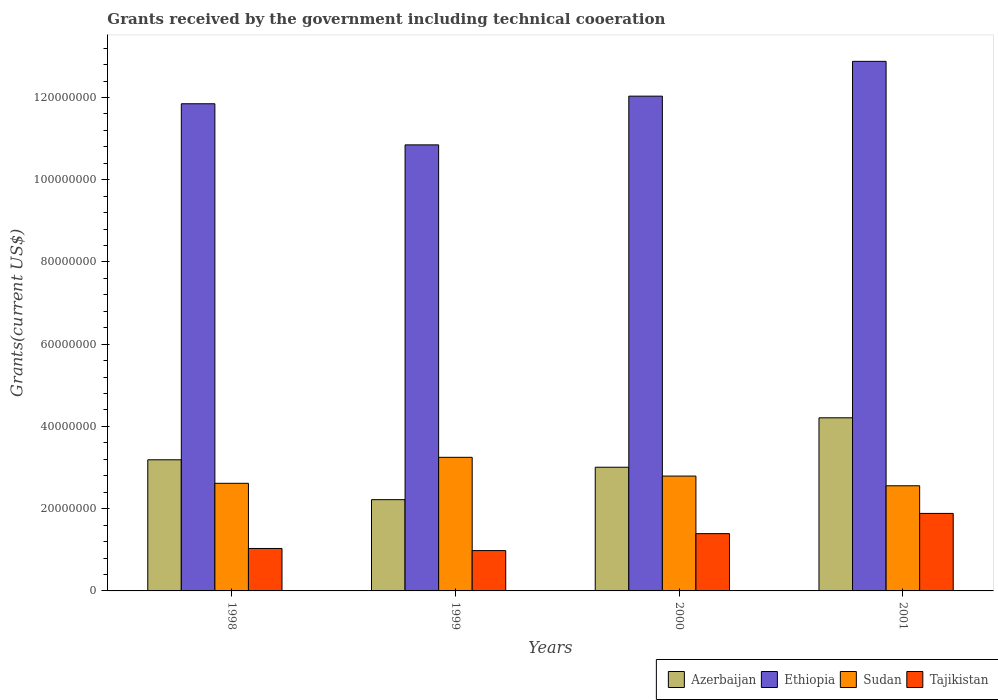How many different coloured bars are there?
Provide a succinct answer. 4. Are the number of bars on each tick of the X-axis equal?
Make the answer very short. Yes. How many bars are there on the 1st tick from the left?
Ensure brevity in your answer.  4. What is the label of the 2nd group of bars from the left?
Give a very brief answer. 1999. What is the total grants received by the government in Sudan in 1999?
Offer a terse response. 3.25e+07. Across all years, what is the maximum total grants received by the government in Ethiopia?
Ensure brevity in your answer.  1.29e+08. Across all years, what is the minimum total grants received by the government in Ethiopia?
Make the answer very short. 1.08e+08. In which year was the total grants received by the government in Tajikistan maximum?
Offer a very short reply. 2001. In which year was the total grants received by the government in Azerbaijan minimum?
Offer a terse response. 1999. What is the total total grants received by the government in Azerbaijan in the graph?
Offer a terse response. 1.26e+08. What is the difference between the total grants received by the government in Azerbaijan in 1999 and that in 2000?
Give a very brief answer. -7.89e+06. What is the difference between the total grants received by the government in Azerbaijan in 2000 and the total grants received by the government in Ethiopia in 2001?
Your answer should be very brief. -9.87e+07. What is the average total grants received by the government in Sudan per year?
Your answer should be compact. 2.80e+07. In the year 1999, what is the difference between the total grants received by the government in Tajikistan and total grants received by the government in Ethiopia?
Give a very brief answer. -9.87e+07. What is the ratio of the total grants received by the government in Sudan in 1999 to that in 2001?
Make the answer very short. 1.27. What is the difference between the highest and the second highest total grants received by the government in Tajikistan?
Offer a very short reply. 4.92e+06. What is the difference between the highest and the lowest total grants received by the government in Azerbaijan?
Provide a short and direct response. 1.99e+07. What does the 3rd bar from the left in 1999 represents?
Your response must be concise. Sudan. What does the 1st bar from the right in 1998 represents?
Offer a very short reply. Tajikistan. Is it the case that in every year, the sum of the total grants received by the government in Ethiopia and total grants received by the government in Tajikistan is greater than the total grants received by the government in Azerbaijan?
Make the answer very short. Yes. Are all the bars in the graph horizontal?
Your answer should be compact. No. Does the graph contain any zero values?
Keep it short and to the point. No. Does the graph contain grids?
Offer a very short reply. No. Where does the legend appear in the graph?
Make the answer very short. Bottom right. How many legend labels are there?
Keep it short and to the point. 4. How are the legend labels stacked?
Provide a succinct answer. Horizontal. What is the title of the graph?
Your response must be concise. Grants received by the government including technical cooeration. What is the label or title of the X-axis?
Offer a very short reply. Years. What is the label or title of the Y-axis?
Your answer should be compact. Grants(current US$). What is the Grants(current US$) of Azerbaijan in 1998?
Offer a very short reply. 3.19e+07. What is the Grants(current US$) of Ethiopia in 1998?
Provide a short and direct response. 1.18e+08. What is the Grants(current US$) in Sudan in 1998?
Provide a succinct answer. 2.62e+07. What is the Grants(current US$) in Tajikistan in 1998?
Your answer should be compact. 1.03e+07. What is the Grants(current US$) in Azerbaijan in 1999?
Your response must be concise. 2.22e+07. What is the Grants(current US$) in Ethiopia in 1999?
Provide a short and direct response. 1.08e+08. What is the Grants(current US$) of Sudan in 1999?
Your response must be concise. 3.25e+07. What is the Grants(current US$) of Tajikistan in 1999?
Make the answer very short. 9.81e+06. What is the Grants(current US$) of Azerbaijan in 2000?
Make the answer very short. 3.01e+07. What is the Grants(current US$) of Ethiopia in 2000?
Your answer should be very brief. 1.20e+08. What is the Grants(current US$) of Sudan in 2000?
Ensure brevity in your answer.  2.79e+07. What is the Grants(current US$) in Tajikistan in 2000?
Keep it short and to the point. 1.39e+07. What is the Grants(current US$) of Azerbaijan in 2001?
Give a very brief answer. 4.21e+07. What is the Grants(current US$) in Ethiopia in 2001?
Offer a terse response. 1.29e+08. What is the Grants(current US$) of Sudan in 2001?
Ensure brevity in your answer.  2.56e+07. What is the Grants(current US$) in Tajikistan in 2001?
Offer a terse response. 1.88e+07. Across all years, what is the maximum Grants(current US$) of Azerbaijan?
Ensure brevity in your answer.  4.21e+07. Across all years, what is the maximum Grants(current US$) in Ethiopia?
Provide a succinct answer. 1.29e+08. Across all years, what is the maximum Grants(current US$) of Sudan?
Ensure brevity in your answer.  3.25e+07. Across all years, what is the maximum Grants(current US$) in Tajikistan?
Your answer should be compact. 1.88e+07. Across all years, what is the minimum Grants(current US$) of Azerbaijan?
Provide a succinct answer. 2.22e+07. Across all years, what is the minimum Grants(current US$) in Ethiopia?
Offer a very short reply. 1.08e+08. Across all years, what is the minimum Grants(current US$) of Sudan?
Provide a short and direct response. 2.56e+07. Across all years, what is the minimum Grants(current US$) of Tajikistan?
Provide a short and direct response. 9.81e+06. What is the total Grants(current US$) in Azerbaijan in the graph?
Your response must be concise. 1.26e+08. What is the total Grants(current US$) in Ethiopia in the graph?
Your answer should be compact. 4.76e+08. What is the total Grants(current US$) in Sudan in the graph?
Provide a succinct answer. 1.12e+08. What is the total Grants(current US$) of Tajikistan in the graph?
Provide a succinct answer. 5.29e+07. What is the difference between the Grants(current US$) of Azerbaijan in 1998 and that in 1999?
Your response must be concise. 9.70e+06. What is the difference between the Grants(current US$) of Ethiopia in 1998 and that in 1999?
Your response must be concise. 1.00e+07. What is the difference between the Grants(current US$) in Sudan in 1998 and that in 1999?
Your response must be concise. -6.32e+06. What is the difference between the Grants(current US$) of Tajikistan in 1998 and that in 1999?
Keep it short and to the point. 5.10e+05. What is the difference between the Grants(current US$) of Azerbaijan in 1998 and that in 2000?
Your answer should be compact. 1.81e+06. What is the difference between the Grants(current US$) of Ethiopia in 1998 and that in 2000?
Your answer should be compact. -1.85e+06. What is the difference between the Grants(current US$) in Sudan in 1998 and that in 2000?
Give a very brief answer. -1.76e+06. What is the difference between the Grants(current US$) in Tajikistan in 1998 and that in 2000?
Make the answer very short. -3.61e+06. What is the difference between the Grants(current US$) of Azerbaijan in 1998 and that in 2001?
Your answer should be compact. -1.02e+07. What is the difference between the Grants(current US$) of Ethiopia in 1998 and that in 2001?
Provide a short and direct response. -1.03e+07. What is the difference between the Grants(current US$) of Sudan in 1998 and that in 2001?
Ensure brevity in your answer.  6.00e+05. What is the difference between the Grants(current US$) of Tajikistan in 1998 and that in 2001?
Ensure brevity in your answer.  -8.53e+06. What is the difference between the Grants(current US$) of Azerbaijan in 1999 and that in 2000?
Make the answer very short. -7.89e+06. What is the difference between the Grants(current US$) in Ethiopia in 1999 and that in 2000?
Your answer should be very brief. -1.18e+07. What is the difference between the Grants(current US$) of Sudan in 1999 and that in 2000?
Give a very brief answer. 4.56e+06. What is the difference between the Grants(current US$) in Tajikistan in 1999 and that in 2000?
Provide a short and direct response. -4.12e+06. What is the difference between the Grants(current US$) of Azerbaijan in 1999 and that in 2001?
Your response must be concise. -1.99e+07. What is the difference between the Grants(current US$) in Ethiopia in 1999 and that in 2001?
Your response must be concise. -2.03e+07. What is the difference between the Grants(current US$) of Sudan in 1999 and that in 2001?
Your answer should be compact. 6.92e+06. What is the difference between the Grants(current US$) of Tajikistan in 1999 and that in 2001?
Your answer should be very brief. -9.04e+06. What is the difference between the Grants(current US$) of Azerbaijan in 2000 and that in 2001?
Your answer should be very brief. -1.20e+07. What is the difference between the Grants(current US$) in Ethiopia in 2000 and that in 2001?
Provide a short and direct response. -8.46e+06. What is the difference between the Grants(current US$) in Sudan in 2000 and that in 2001?
Keep it short and to the point. 2.36e+06. What is the difference between the Grants(current US$) in Tajikistan in 2000 and that in 2001?
Provide a succinct answer. -4.92e+06. What is the difference between the Grants(current US$) in Azerbaijan in 1998 and the Grants(current US$) in Ethiopia in 1999?
Your response must be concise. -7.66e+07. What is the difference between the Grants(current US$) of Azerbaijan in 1998 and the Grants(current US$) of Sudan in 1999?
Provide a short and direct response. -6.00e+05. What is the difference between the Grants(current US$) of Azerbaijan in 1998 and the Grants(current US$) of Tajikistan in 1999?
Give a very brief answer. 2.21e+07. What is the difference between the Grants(current US$) in Ethiopia in 1998 and the Grants(current US$) in Sudan in 1999?
Give a very brief answer. 8.60e+07. What is the difference between the Grants(current US$) of Ethiopia in 1998 and the Grants(current US$) of Tajikistan in 1999?
Your response must be concise. 1.09e+08. What is the difference between the Grants(current US$) in Sudan in 1998 and the Grants(current US$) in Tajikistan in 1999?
Ensure brevity in your answer.  1.64e+07. What is the difference between the Grants(current US$) in Azerbaijan in 1998 and the Grants(current US$) in Ethiopia in 2000?
Your answer should be very brief. -8.84e+07. What is the difference between the Grants(current US$) of Azerbaijan in 1998 and the Grants(current US$) of Sudan in 2000?
Keep it short and to the point. 3.96e+06. What is the difference between the Grants(current US$) in Azerbaijan in 1998 and the Grants(current US$) in Tajikistan in 2000?
Provide a succinct answer. 1.80e+07. What is the difference between the Grants(current US$) in Ethiopia in 1998 and the Grants(current US$) in Sudan in 2000?
Your response must be concise. 9.05e+07. What is the difference between the Grants(current US$) in Ethiopia in 1998 and the Grants(current US$) in Tajikistan in 2000?
Provide a short and direct response. 1.05e+08. What is the difference between the Grants(current US$) in Sudan in 1998 and the Grants(current US$) in Tajikistan in 2000?
Offer a terse response. 1.22e+07. What is the difference between the Grants(current US$) in Azerbaijan in 1998 and the Grants(current US$) in Ethiopia in 2001?
Give a very brief answer. -9.69e+07. What is the difference between the Grants(current US$) of Azerbaijan in 1998 and the Grants(current US$) of Sudan in 2001?
Make the answer very short. 6.32e+06. What is the difference between the Grants(current US$) in Azerbaijan in 1998 and the Grants(current US$) in Tajikistan in 2001?
Your answer should be compact. 1.30e+07. What is the difference between the Grants(current US$) in Ethiopia in 1998 and the Grants(current US$) in Sudan in 2001?
Your answer should be very brief. 9.29e+07. What is the difference between the Grants(current US$) of Ethiopia in 1998 and the Grants(current US$) of Tajikistan in 2001?
Provide a succinct answer. 9.96e+07. What is the difference between the Grants(current US$) of Sudan in 1998 and the Grants(current US$) of Tajikistan in 2001?
Keep it short and to the point. 7.32e+06. What is the difference between the Grants(current US$) in Azerbaijan in 1999 and the Grants(current US$) in Ethiopia in 2000?
Ensure brevity in your answer.  -9.81e+07. What is the difference between the Grants(current US$) in Azerbaijan in 1999 and the Grants(current US$) in Sudan in 2000?
Provide a succinct answer. -5.74e+06. What is the difference between the Grants(current US$) of Azerbaijan in 1999 and the Grants(current US$) of Tajikistan in 2000?
Offer a very short reply. 8.26e+06. What is the difference between the Grants(current US$) in Ethiopia in 1999 and the Grants(current US$) in Sudan in 2000?
Your answer should be compact. 8.05e+07. What is the difference between the Grants(current US$) in Ethiopia in 1999 and the Grants(current US$) in Tajikistan in 2000?
Offer a very short reply. 9.45e+07. What is the difference between the Grants(current US$) of Sudan in 1999 and the Grants(current US$) of Tajikistan in 2000?
Give a very brief answer. 1.86e+07. What is the difference between the Grants(current US$) in Azerbaijan in 1999 and the Grants(current US$) in Ethiopia in 2001?
Your answer should be compact. -1.07e+08. What is the difference between the Grants(current US$) in Azerbaijan in 1999 and the Grants(current US$) in Sudan in 2001?
Ensure brevity in your answer.  -3.38e+06. What is the difference between the Grants(current US$) of Azerbaijan in 1999 and the Grants(current US$) of Tajikistan in 2001?
Offer a terse response. 3.34e+06. What is the difference between the Grants(current US$) in Ethiopia in 1999 and the Grants(current US$) in Sudan in 2001?
Your answer should be very brief. 8.29e+07. What is the difference between the Grants(current US$) of Ethiopia in 1999 and the Grants(current US$) of Tajikistan in 2001?
Provide a short and direct response. 8.96e+07. What is the difference between the Grants(current US$) in Sudan in 1999 and the Grants(current US$) in Tajikistan in 2001?
Give a very brief answer. 1.36e+07. What is the difference between the Grants(current US$) in Azerbaijan in 2000 and the Grants(current US$) in Ethiopia in 2001?
Ensure brevity in your answer.  -9.87e+07. What is the difference between the Grants(current US$) of Azerbaijan in 2000 and the Grants(current US$) of Sudan in 2001?
Provide a succinct answer. 4.51e+06. What is the difference between the Grants(current US$) of Azerbaijan in 2000 and the Grants(current US$) of Tajikistan in 2001?
Offer a terse response. 1.12e+07. What is the difference between the Grants(current US$) in Ethiopia in 2000 and the Grants(current US$) in Sudan in 2001?
Your answer should be compact. 9.48e+07. What is the difference between the Grants(current US$) of Ethiopia in 2000 and the Grants(current US$) of Tajikistan in 2001?
Offer a terse response. 1.01e+08. What is the difference between the Grants(current US$) in Sudan in 2000 and the Grants(current US$) in Tajikistan in 2001?
Your response must be concise. 9.08e+06. What is the average Grants(current US$) of Azerbaijan per year?
Your answer should be compact. 3.16e+07. What is the average Grants(current US$) in Ethiopia per year?
Offer a terse response. 1.19e+08. What is the average Grants(current US$) in Sudan per year?
Offer a terse response. 2.80e+07. What is the average Grants(current US$) in Tajikistan per year?
Provide a short and direct response. 1.32e+07. In the year 1998, what is the difference between the Grants(current US$) of Azerbaijan and Grants(current US$) of Ethiopia?
Keep it short and to the point. -8.66e+07. In the year 1998, what is the difference between the Grants(current US$) of Azerbaijan and Grants(current US$) of Sudan?
Ensure brevity in your answer.  5.72e+06. In the year 1998, what is the difference between the Grants(current US$) of Azerbaijan and Grants(current US$) of Tajikistan?
Provide a succinct answer. 2.16e+07. In the year 1998, what is the difference between the Grants(current US$) in Ethiopia and Grants(current US$) in Sudan?
Keep it short and to the point. 9.23e+07. In the year 1998, what is the difference between the Grants(current US$) in Ethiopia and Grants(current US$) in Tajikistan?
Offer a very short reply. 1.08e+08. In the year 1998, what is the difference between the Grants(current US$) of Sudan and Grants(current US$) of Tajikistan?
Keep it short and to the point. 1.58e+07. In the year 1999, what is the difference between the Grants(current US$) in Azerbaijan and Grants(current US$) in Ethiopia?
Offer a very short reply. -8.63e+07. In the year 1999, what is the difference between the Grants(current US$) of Azerbaijan and Grants(current US$) of Sudan?
Offer a terse response. -1.03e+07. In the year 1999, what is the difference between the Grants(current US$) in Azerbaijan and Grants(current US$) in Tajikistan?
Make the answer very short. 1.24e+07. In the year 1999, what is the difference between the Grants(current US$) in Ethiopia and Grants(current US$) in Sudan?
Ensure brevity in your answer.  7.60e+07. In the year 1999, what is the difference between the Grants(current US$) of Ethiopia and Grants(current US$) of Tajikistan?
Your answer should be compact. 9.87e+07. In the year 1999, what is the difference between the Grants(current US$) of Sudan and Grants(current US$) of Tajikistan?
Offer a terse response. 2.27e+07. In the year 2000, what is the difference between the Grants(current US$) of Azerbaijan and Grants(current US$) of Ethiopia?
Give a very brief answer. -9.02e+07. In the year 2000, what is the difference between the Grants(current US$) in Azerbaijan and Grants(current US$) in Sudan?
Offer a terse response. 2.15e+06. In the year 2000, what is the difference between the Grants(current US$) in Azerbaijan and Grants(current US$) in Tajikistan?
Make the answer very short. 1.62e+07. In the year 2000, what is the difference between the Grants(current US$) in Ethiopia and Grants(current US$) in Sudan?
Provide a succinct answer. 9.24e+07. In the year 2000, what is the difference between the Grants(current US$) in Ethiopia and Grants(current US$) in Tajikistan?
Your response must be concise. 1.06e+08. In the year 2000, what is the difference between the Grants(current US$) of Sudan and Grants(current US$) of Tajikistan?
Make the answer very short. 1.40e+07. In the year 2001, what is the difference between the Grants(current US$) of Azerbaijan and Grants(current US$) of Ethiopia?
Your answer should be very brief. -8.67e+07. In the year 2001, what is the difference between the Grants(current US$) of Azerbaijan and Grants(current US$) of Sudan?
Offer a terse response. 1.65e+07. In the year 2001, what is the difference between the Grants(current US$) in Azerbaijan and Grants(current US$) in Tajikistan?
Your answer should be compact. 2.32e+07. In the year 2001, what is the difference between the Grants(current US$) in Ethiopia and Grants(current US$) in Sudan?
Provide a short and direct response. 1.03e+08. In the year 2001, what is the difference between the Grants(current US$) in Ethiopia and Grants(current US$) in Tajikistan?
Provide a short and direct response. 1.10e+08. In the year 2001, what is the difference between the Grants(current US$) of Sudan and Grants(current US$) of Tajikistan?
Your answer should be compact. 6.72e+06. What is the ratio of the Grants(current US$) in Azerbaijan in 1998 to that in 1999?
Make the answer very short. 1.44. What is the ratio of the Grants(current US$) in Ethiopia in 1998 to that in 1999?
Your answer should be very brief. 1.09. What is the ratio of the Grants(current US$) of Sudan in 1998 to that in 1999?
Give a very brief answer. 0.81. What is the ratio of the Grants(current US$) in Tajikistan in 1998 to that in 1999?
Your answer should be very brief. 1.05. What is the ratio of the Grants(current US$) of Azerbaijan in 1998 to that in 2000?
Provide a succinct answer. 1.06. What is the ratio of the Grants(current US$) in Ethiopia in 1998 to that in 2000?
Keep it short and to the point. 0.98. What is the ratio of the Grants(current US$) of Sudan in 1998 to that in 2000?
Offer a very short reply. 0.94. What is the ratio of the Grants(current US$) of Tajikistan in 1998 to that in 2000?
Make the answer very short. 0.74. What is the ratio of the Grants(current US$) of Azerbaijan in 1998 to that in 2001?
Your answer should be compact. 0.76. What is the ratio of the Grants(current US$) in Ethiopia in 1998 to that in 2001?
Keep it short and to the point. 0.92. What is the ratio of the Grants(current US$) in Sudan in 1998 to that in 2001?
Provide a succinct answer. 1.02. What is the ratio of the Grants(current US$) of Tajikistan in 1998 to that in 2001?
Your answer should be compact. 0.55. What is the ratio of the Grants(current US$) in Azerbaijan in 1999 to that in 2000?
Give a very brief answer. 0.74. What is the ratio of the Grants(current US$) in Ethiopia in 1999 to that in 2000?
Give a very brief answer. 0.9. What is the ratio of the Grants(current US$) of Sudan in 1999 to that in 2000?
Provide a short and direct response. 1.16. What is the ratio of the Grants(current US$) in Tajikistan in 1999 to that in 2000?
Ensure brevity in your answer.  0.7. What is the ratio of the Grants(current US$) of Azerbaijan in 1999 to that in 2001?
Your answer should be very brief. 0.53. What is the ratio of the Grants(current US$) of Ethiopia in 1999 to that in 2001?
Provide a succinct answer. 0.84. What is the ratio of the Grants(current US$) in Sudan in 1999 to that in 2001?
Your answer should be very brief. 1.27. What is the ratio of the Grants(current US$) in Tajikistan in 1999 to that in 2001?
Provide a short and direct response. 0.52. What is the ratio of the Grants(current US$) of Azerbaijan in 2000 to that in 2001?
Offer a very short reply. 0.71. What is the ratio of the Grants(current US$) of Ethiopia in 2000 to that in 2001?
Provide a short and direct response. 0.93. What is the ratio of the Grants(current US$) in Sudan in 2000 to that in 2001?
Offer a terse response. 1.09. What is the ratio of the Grants(current US$) in Tajikistan in 2000 to that in 2001?
Offer a terse response. 0.74. What is the difference between the highest and the second highest Grants(current US$) in Azerbaijan?
Make the answer very short. 1.02e+07. What is the difference between the highest and the second highest Grants(current US$) in Ethiopia?
Provide a succinct answer. 8.46e+06. What is the difference between the highest and the second highest Grants(current US$) in Sudan?
Make the answer very short. 4.56e+06. What is the difference between the highest and the second highest Grants(current US$) in Tajikistan?
Ensure brevity in your answer.  4.92e+06. What is the difference between the highest and the lowest Grants(current US$) of Azerbaijan?
Make the answer very short. 1.99e+07. What is the difference between the highest and the lowest Grants(current US$) of Ethiopia?
Give a very brief answer. 2.03e+07. What is the difference between the highest and the lowest Grants(current US$) of Sudan?
Keep it short and to the point. 6.92e+06. What is the difference between the highest and the lowest Grants(current US$) in Tajikistan?
Offer a very short reply. 9.04e+06. 